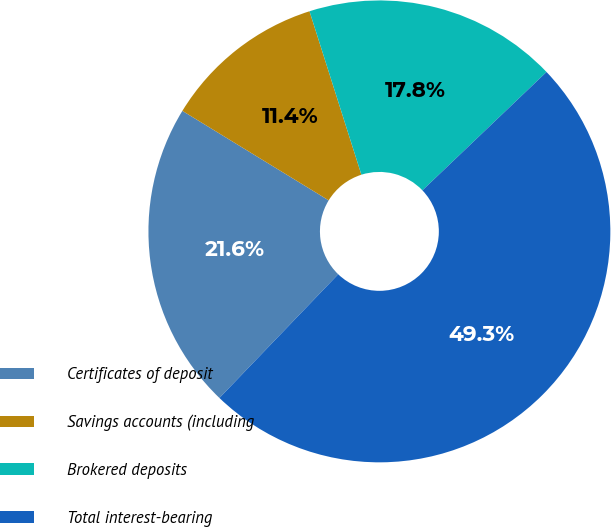Convert chart. <chart><loc_0><loc_0><loc_500><loc_500><pie_chart><fcel>Certificates of deposit<fcel>Savings accounts (including<fcel>Brokered deposits<fcel>Total interest-bearing<nl><fcel>21.56%<fcel>11.37%<fcel>17.77%<fcel>49.3%<nl></chart> 